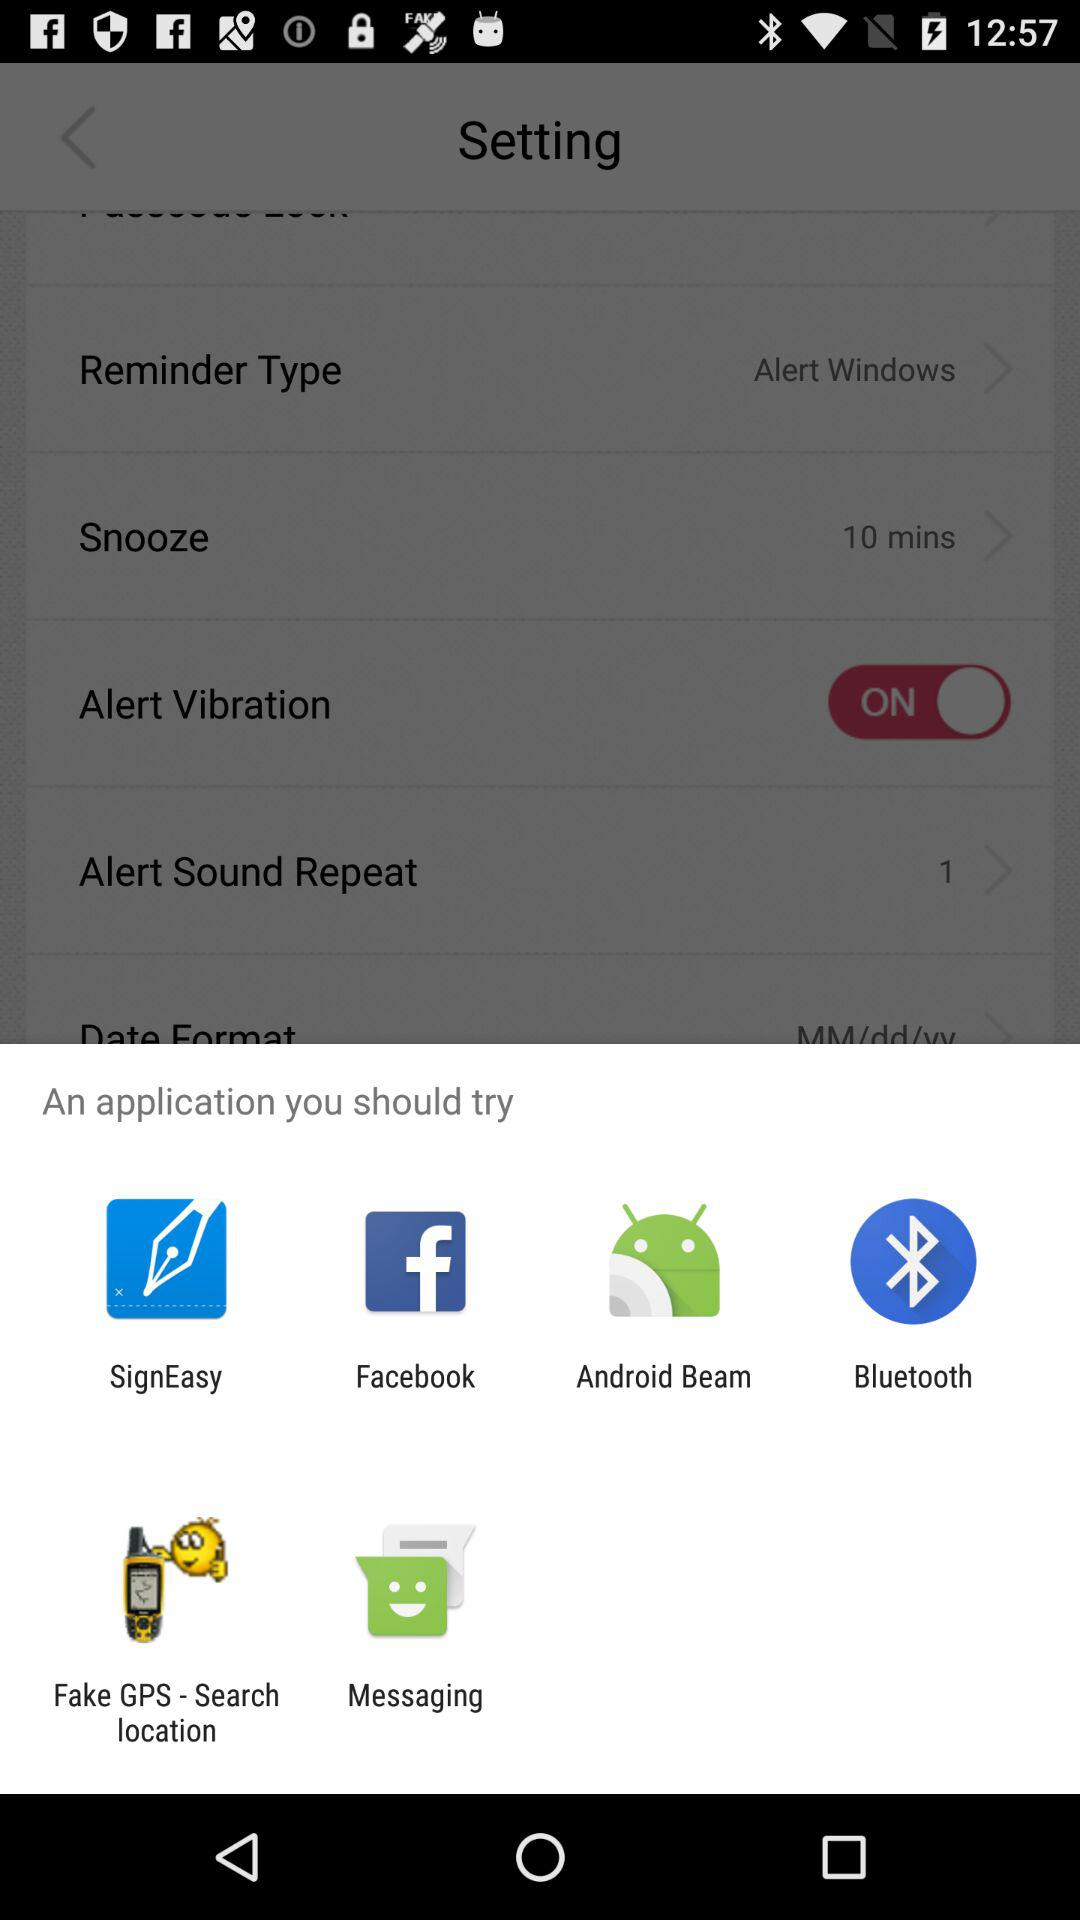What is the list of applications that are available to try? The applications are "SignEasy", "Facebook", "Android Beam", "Bluetooth", "Fake GPS - Search location" and "Messaging". 